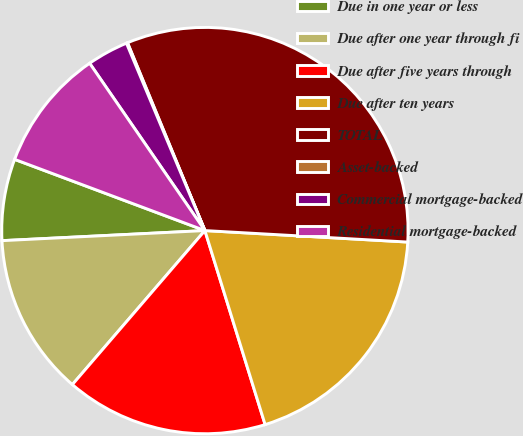<chart> <loc_0><loc_0><loc_500><loc_500><pie_chart><fcel>Due in one year or less<fcel>Due after one year through fi<fcel>Due after five years through<fcel>Due after ten years<fcel>TOTAL<fcel>Asset-backed<fcel>Commercial mortgage-backed<fcel>Residential mortgage-backed<nl><fcel>6.49%<fcel>12.9%<fcel>16.1%<fcel>19.31%<fcel>32.12%<fcel>0.09%<fcel>3.29%<fcel>9.7%<nl></chart> 